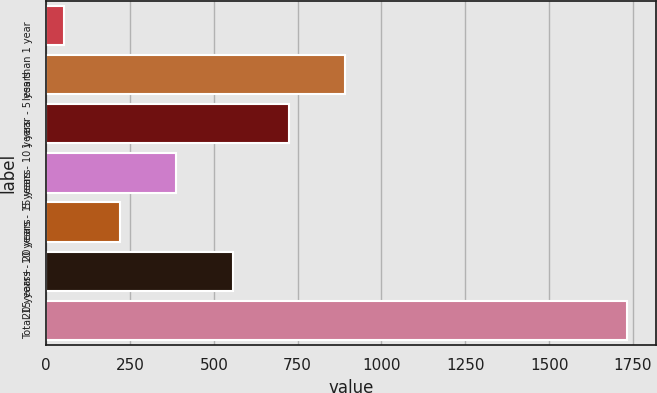Convert chart to OTSL. <chart><loc_0><loc_0><loc_500><loc_500><bar_chart><fcel>less than 1 year<fcel>1 year - 5 years<fcel>5 years - 10 years<fcel>10 years - 15 years<fcel>15 years - 20 years<fcel>20 years+<fcel>Total<nl><fcel>53<fcel>892<fcel>724.2<fcel>388.6<fcel>220.8<fcel>556.4<fcel>1731<nl></chart> 